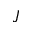<formula> <loc_0><loc_0><loc_500><loc_500>J</formula> 